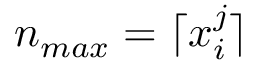<formula> <loc_0><loc_0><loc_500><loc_500>n _ { \max } = \lceil x _ { i } ^ { j } \rceil</formula> 